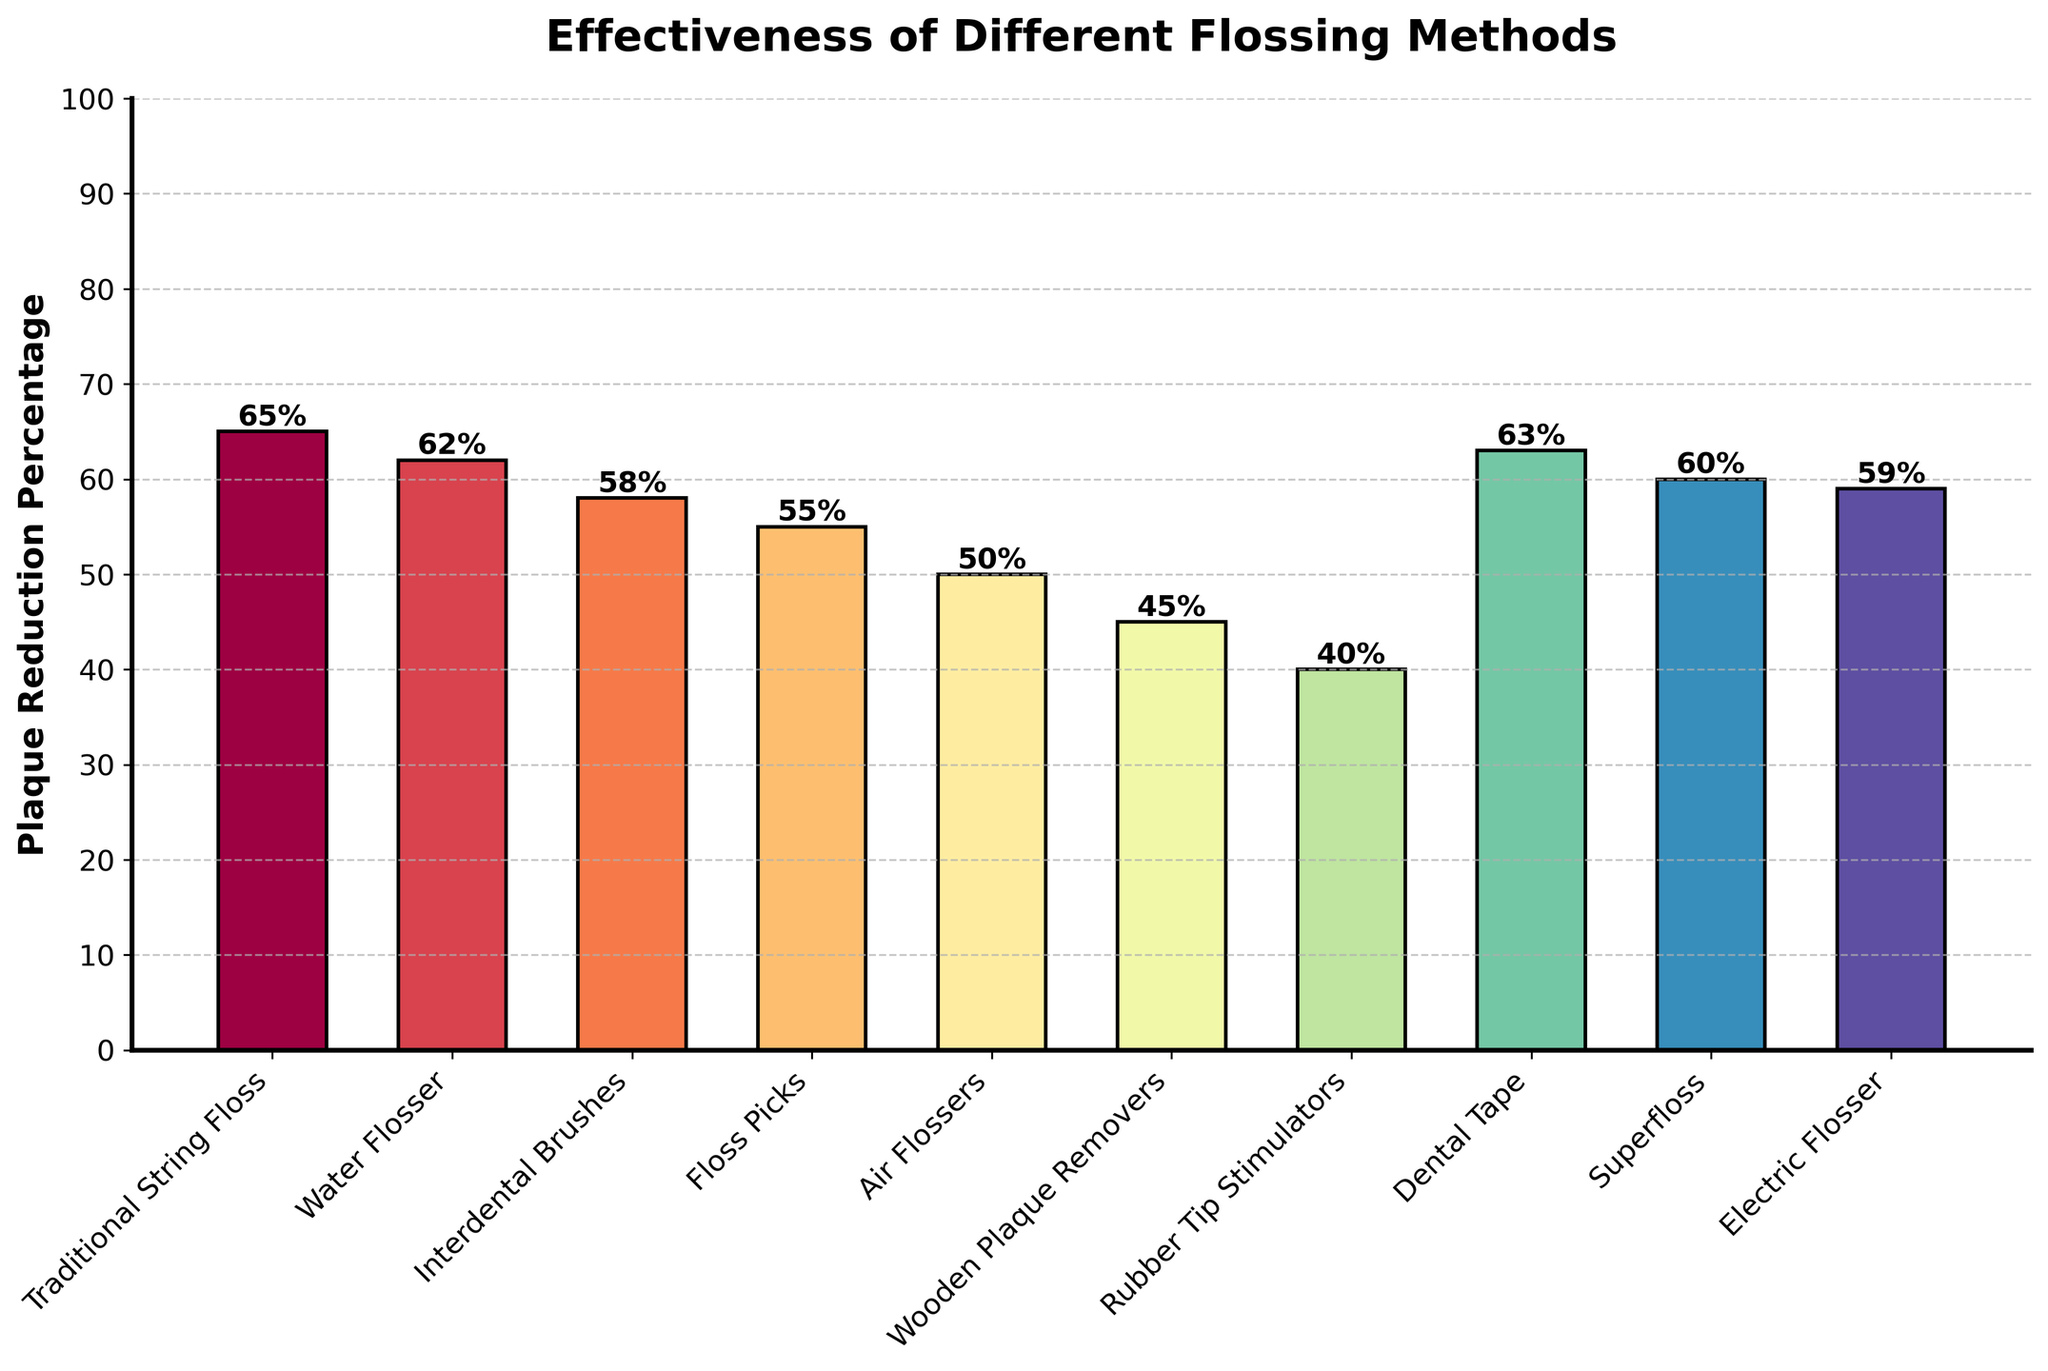what is the plaque reduction percentage for Traditional String Floss? The figure shows the percentage each flossing method reduces plaque. Look for "Traditional String Floss" and read the corresponding bar label.
Answer: 65% Which flossing method is the least effective at reducing plaque? Examine the bars to find the shortest one, representing the lowest plaque reduction percentage among all methods.
Answer: Rubber Tip Stimulators What method stands second in terms of plaque reduction effectiveness? Identify the bar with the second-highest height among all methods.
Answer: Dental Tape What is the sum of plaque reduction percentages for Water Flosser and Electric Flosser? Locate the Water Flosser and Electric Flosser bars to find their percentages, then sum them. Water Flosser is 62% and Electric Flosser is 59%. 62 + 59 = 121
Answer: 121% Which method is more effective: Interdental Brushes or Floss Picks? Compare the heights of the bars for Interdental Brushes and Floss Picks to determine which is taller.
Answer: Interdental Brushes What is the average plaque reduction percentage for Traditional String Floss, Dental Tape, and Superfloss? Locate each corresponding bar for the methods and calculate their average. Traditional String Floss is 65%, Dental Tape is 63%, and Superfloss is 60%. (65 + 63 + 60) / 3 = 62.67
Answer: 62.67% By how many percentage points is the most effective method better than the least effective method? Find the difference between the highest and lowest plaque reduction percentages. The most effective method is Traditional String Floss at 65%, and the least effective is Rubber Tip Stimulators at 40%. 65 - 40 = 25
Answer: 25 Which method has the same plaque reduction percentage as Superfloss? Identify any other bars with the same height as the Superfloss bar, which is 60%.
Answer: No method matches Superfloss How many flossing methods achieve a plaque reduction percentage of 55% or more? Count the number of bars with heights at or above 55%. Methods include Traditional String Floss, Water Flosser, Dental Tape, Superfloss, Interdental Brushes, Floss Picks, and Electric Flosser. There are 7 such methods.
Answer: 7 Is Wooden Plaque Removers less effective than Air Flossers? Compare the heights of the Wooden Plaque Removers and Air Flossers bars. Wooden Plaque Removers reduce plaque by 45%, and Air Flossers by 50%.
Answer: Yes 